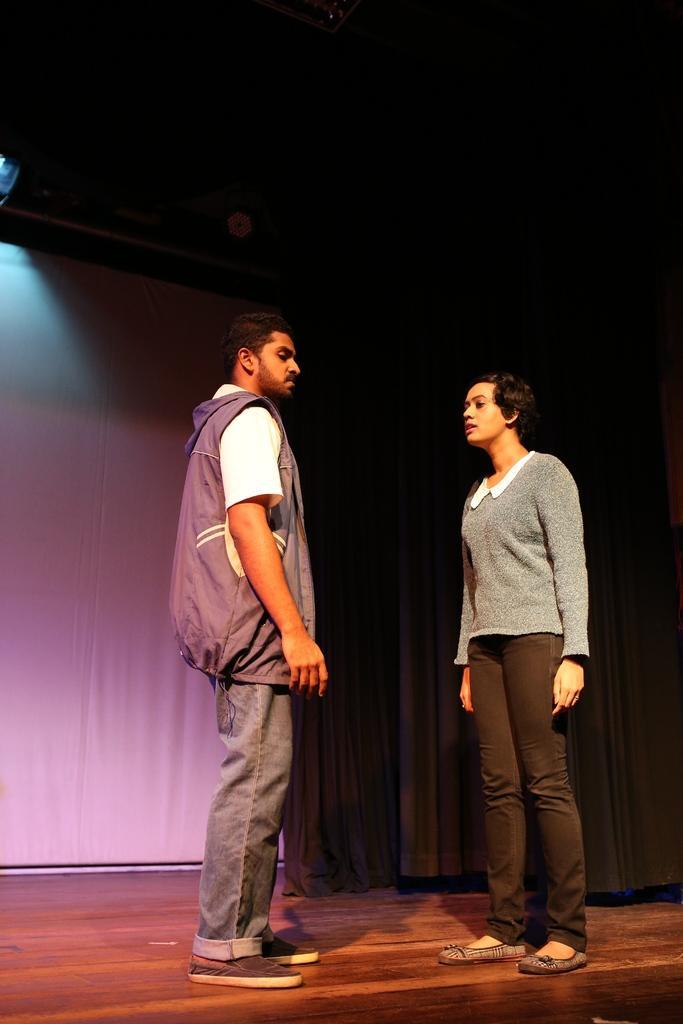Could you give a brief overview of what you see in this image? In the image I can see two people, among them a person is wearing the jacket. 